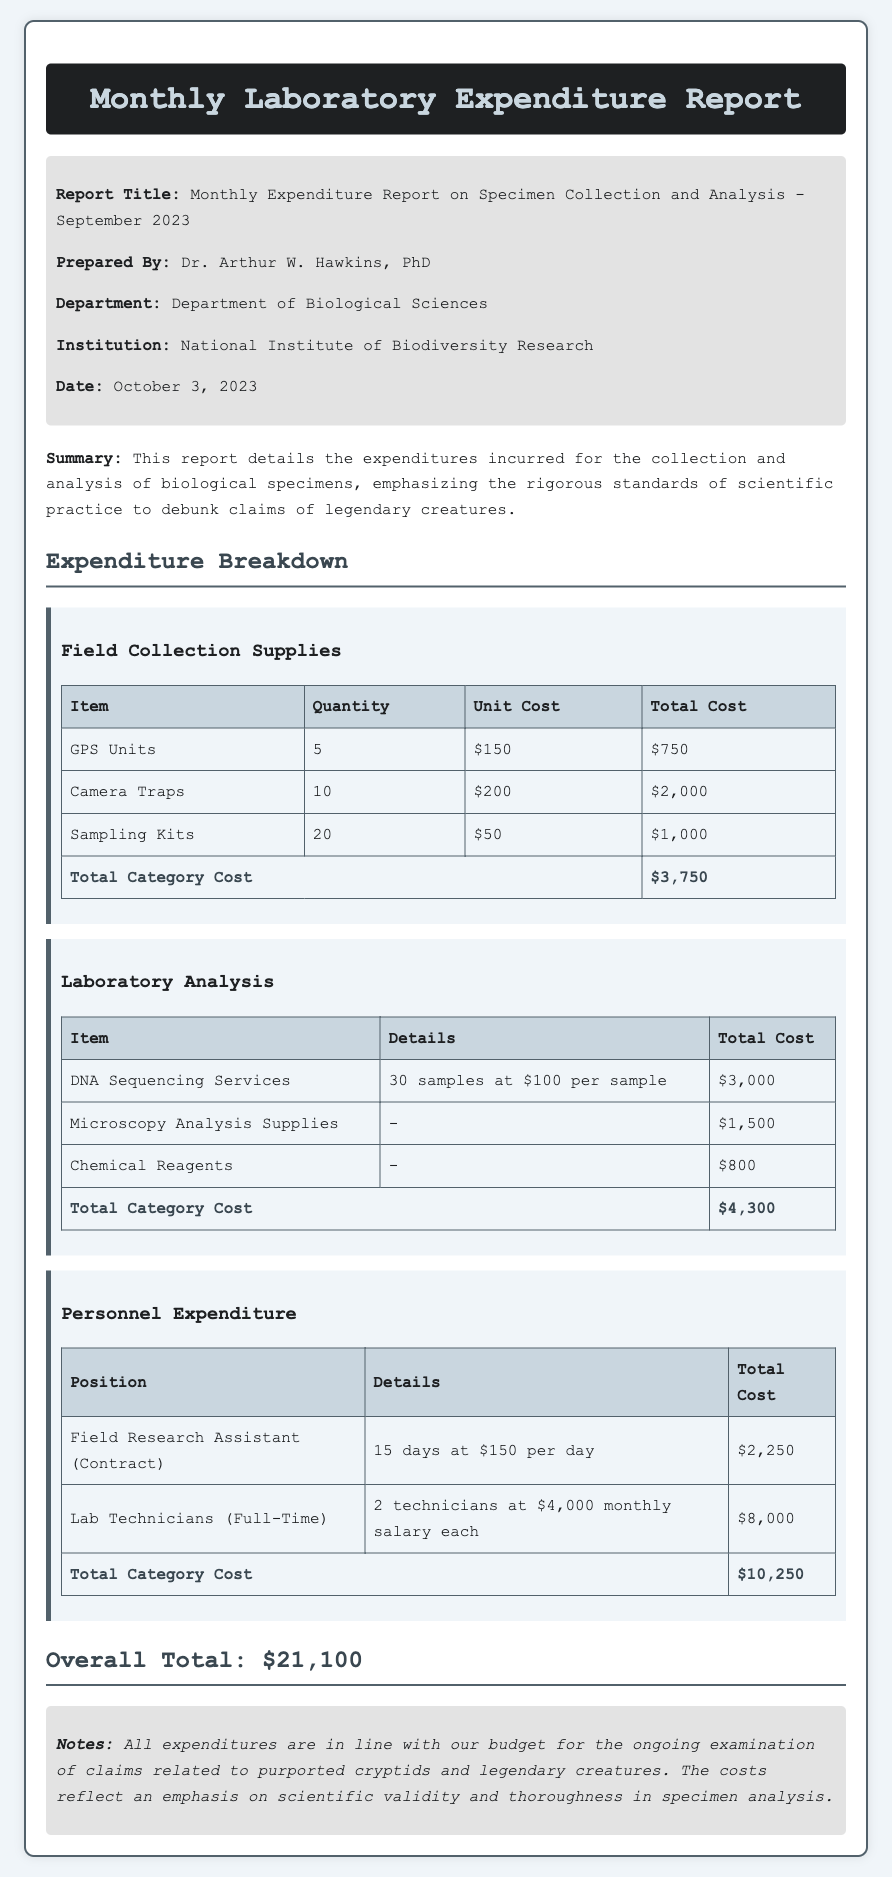what is the report title? The report title is specified at the top of the document.
Answer: Monthly Expenditure Report on Specimen Collection and Analysis - September 2023 who prepared the report? The preparer is mentioned in the info section of the document.
Answer: Dr. Arthur W. Hawkins, PhD what was the total cost for laboratory analysis? This is calculated from the detailed costs listed in the laboratory analysis section.
Answer: $4,300 how many GPS units were purchased? The quantity of GPS units is listed in the field collection supplies table.
Answer: 5 what is the overall total expenditure reported? The overall total is stated at the bottom of the document.
Answer: $21,100 what category had the highest total cost? By comparing the total costs of each category, we identify the highest.
Answer: Personnel Expenditure what date was the report prepared? The prepared date is found in the info section.
Answer: October 3, 2023 how many camera traps were acquired? The quantity of camera traps is specified in the field collection supplies table.
Answer: 10 what is the unit cost of a sampling kit? The unit cost is stated in the field collection supplies table.
Answer: $50 